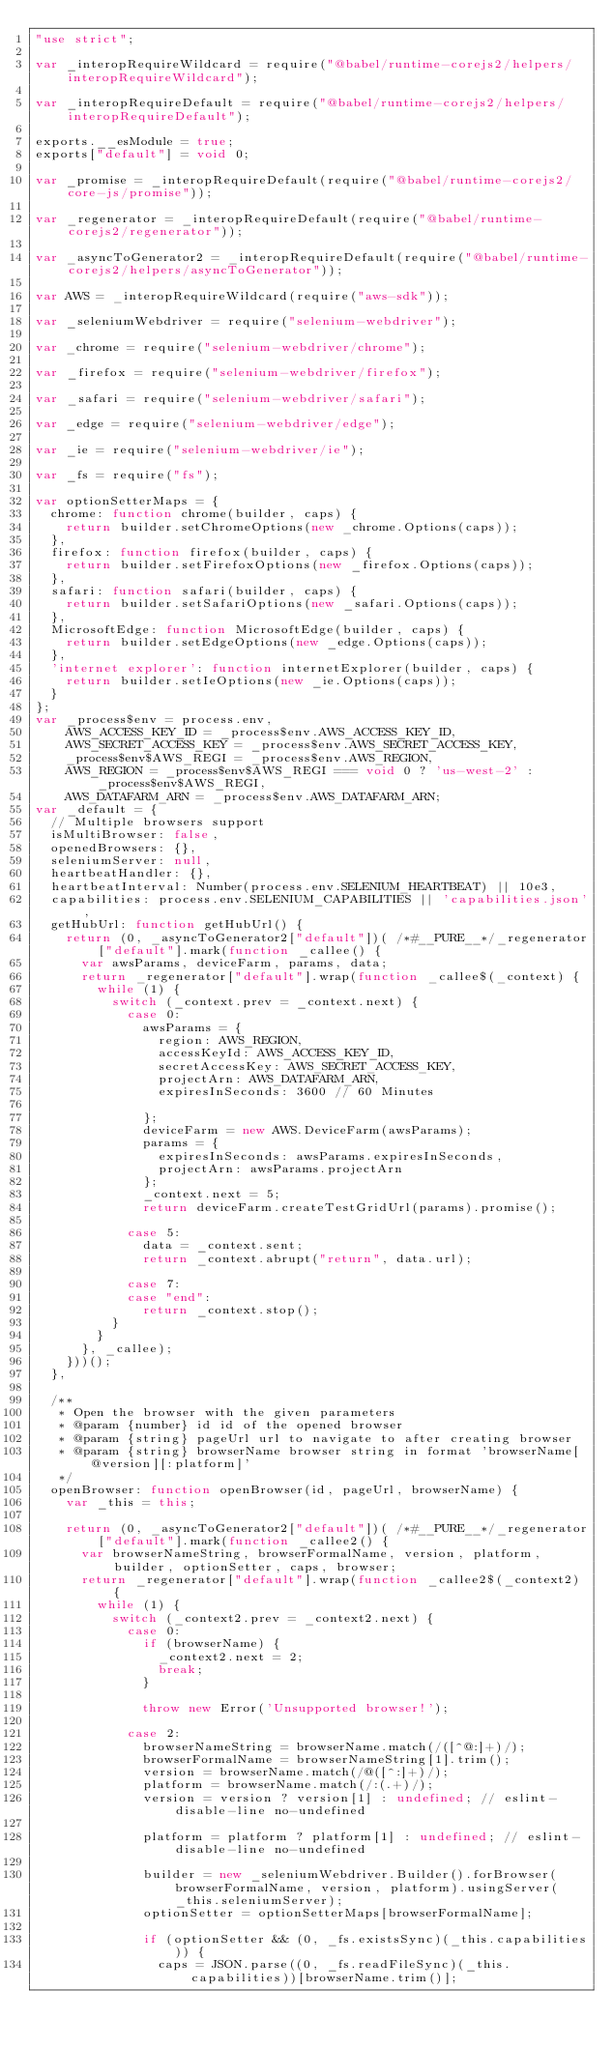<code> <loc_0><loc_0><loc_500><loc_500><_JavaScript_>"use strict";

var _interopRequireWildcard = require("@babel/runtime-corejs2/helpers/interopRequireWildcard");

var _interopRequireDefault = require("@babel/runtime-corejs2/helpers/interopRequireDefault");

exports.__esModule = true;
exports["default"] = void 0;

var _promise = _interopRequireDefault(require("@babel/runtime-corejs2/core-js/promise"));

var _regenerator = _interopRequireDefault(require("@babel/runtime-corejs2/regenerator"));

var _asyncToGenerator2 = _interopRequireDefault(require("@babel/runtime-corejs2/helpers/asyncToGenerator"));

var AWS = _interopRequireWildcard(require("aws-sdk"));

var _seleniumWebdriver = require("selenium-webdriver");

var _chrome = require("selenium-webdriver/chrome");

var _firefox = require("selenium-webdriver/firefox");

var _safari = require("selenium-webdriver/safari");

var _edge = require("selenium-webdriver/edge");

var _ie = require("selenium-webdriver/ie");

var _fs = require("fs");

var optionSetterMaps = {
  chrome: function chrome(builder, caps) {
    return builder.setChromeOptions(new _chrome.Options(caps));
  },
  firefox: function firefox(builder, caps) {
    return builder.setFirefoxOptions(new _firefox.Options(caps));
  },
  safari: function safari(builder, caps) {
    return builder.setSafariOptions(new _safari.Options(caps));
  },
  MicrosoftEdge: function MicrosoftEdge(builder, caps) {
    return builder.setEdgeOptions(new _edge.Options(caps));
  },
  'internet explorer': function internetExplorer(builder, caps) {
    return builder.setIeOptions(new _ie.Options(caps));
  }
};
var _process$env = process.env,
    AWS_ACCESS_KEY_ID = _process$env.AWS_ACCESS_KEY_ID,
    AWS_SECRET_ACCESS_KEY = _process$env.AWS_SECRET_ACCESS_KEY,
    _process$env$AWS_REGI = _process$env.AWS_REGION,
    AWS_REGION = _process$env$AWS_REGI === void 0 ? 'us-west-2' : _process$env$AWS_REGI,
    AWS_DATAFARM_ARN = _process$env.AWS_DATAFARM_ARN;
var _default = {
  // Multiple browsers support
  isMultiBrowser: false,
  openedBrowsers: {},
  seleniumServer: null,
  heartbeatHandler: {},
  heartbeatInterval: Number(process.env.SELENIUM_HEARTBEAT) || 10e3,
  capabilities: process.env.SELENIUM_CAPABILITIES || 'capabilities.json',
  getHubUrl: function getHubUrl() {
    return (0, _asyncToGenerator2["default"])( /*#__PURE__*/_regenerator["default"].mark(function _callee() {
      var awsParams, deviceFarm, params, data;
      return _regenerator["default"].wrap(function _callee$(_context) {
        while (1) {
          switch (_context.prev = _context.next) {
            case 0:
              awsParams = {
                region: AWS_REGION,
                accessKeyId: AWS_ACCESS_KEY_ID,
                secretAccessKey: AWS_SECRET_ACCESS_KEY,
                projectArn: AWS_DATAFARM_ARN,
                expiresInSeconds: 3600 // 60 Minutes

              };
              deviceFarm = new AWS.DeviceFarm(awsParams);
              params = {
                expiresInSeconds: awsParams.expiresInSeconds,
                projectArn: awsParams.projectArn
              };
              _context.next = 5;
              return deviceFarm.createTestGridUrl(params).promise();

            case 5:
              data = _context.sent;
              return _context.abrupt("return", data.url);

            case 7:
            case "end":
              return _context.stop();
          }
        }
      }, _callee);
    }))();
  },

  /**
   * Open the browser with the given parameters
   * @param {number} id id of the opened browser
   * @param {string} pageUrl url to navigate to after creating browser
   * @param {string} browserName browser string in format 'browserName[@version][:platform]'
   */
  openBrowser: function openBrowser(id, pageUrl, browserName) {
    var _this = this;

    return (0, _asyncToGenerator2["default"])( /*#__PURE__*/_regenerator["default"].mark(function _callee2() {
      var browserNameString, browserFormalName, version, platform, builder, optionSetter, caps, browser;
      return _regenerator["default"].wrap(function _callee2$(_context2) {
        while (1) {
          switch (_context2.prev = _context2.next) {
            case 0:
              if (browserName) {
                _context2.next = 2;
                break;
              }

              throw new Error('Unsupported browser!');

            case 2:
              browserNameString = browserName.match(/([^@:]+)/);
              browserFormalName = browserNameString[1].trim();
              version = browserName.match(/@([^:]+)/);
              platform = browserName.match(/:(.+)/);
              version = version ? version[1] : undefined; // eslint-disable-line no-undefined

              platform = platform ? platform[1] : undefined; // eslint-disable-line no-undefined

              builder = new _seleniumWebdriver.Builder().forBrowser(browserFormalName, version, platform).usingServer(_this.seleniumServer);
              optionSetter = optionSetterMaps[browserFormalName];

              if (optionSetter && (0, _fs.existsSync)(_this.capabilities)) {
                caps = JSON.parse((0, _fs.readFileSync)(_this.capabilities))[browserName.trim()];</code> 